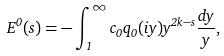<formula> <loc_0><loc_0><loc_500><loc_500>E ^ { 0 } ( s ) = - \int _ { 1 } ^ { \infty } c _ { 0 } q _ { 0 } ( i y ) y ^ { 2 k - s } \frac { d y } { y } ,</formula> 